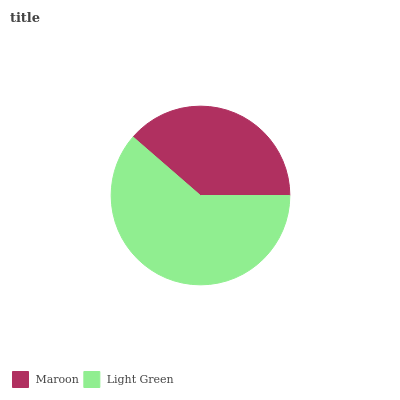Is Maroon the minimum?
Answer yes or no. Yes. Is Light Green the maximum?
Answer yes or no. Yes. Is Light Green the minimum?
Answer yes or no. No. Is Light Green greater than Maroon?
Answer yes or no. Yes. Is Maroon less than Light Green?
Answer yes or no. Yes. Is Maroon greater than Light Green?
Answer yes or no. No. Is Light Green less than Maroon?
Answer yes or no. No. Is Light Green the high median?
Answer yes or no. Yes. Is Maroon the low median?
Answer yes or no. Yes. Is Maroon the high median?
Answer yes or no. No. Is Light Green the low median?
Answer yes or no. No. 